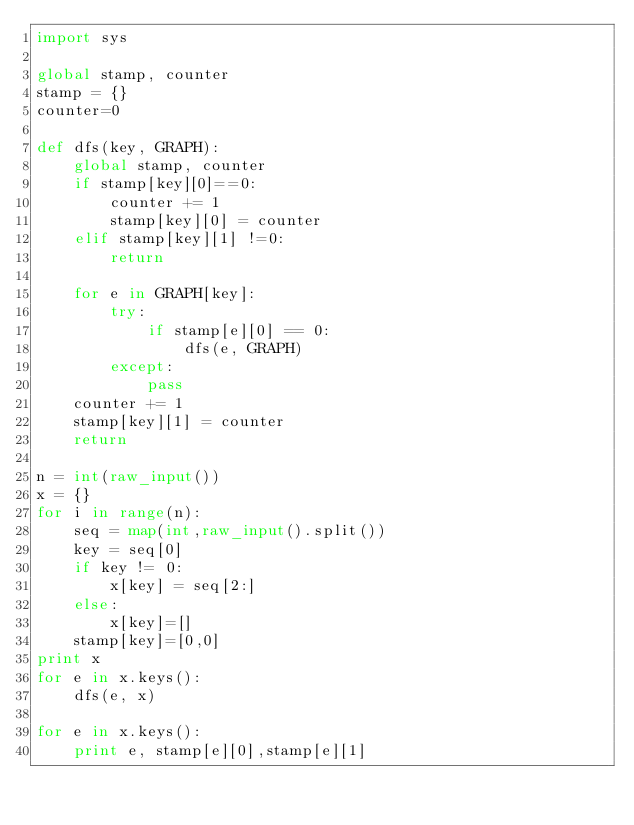<code> <loc_0><loc_0><loc_500><loc_500><_Python_>import sys

global stamp, counter
stamp = {}
counter=0

def dfs(key, GRAPH):
    global stamp, counter
    if stamp[key][0]==0:
        counter += 1
        stamp[key][0] = counter
    elif stamp[key][1] !=0:
        return

    for e in GRAPH[key]:
        try:
            if stamp[e][0] == 0:
                dfs(e, GRAPH)
        except:
            pass
    counter += 1
    stamp[key][1] = counter
    return

n = int(raw_input())
x = {}
for i in range(n):
    seq = map(int,raw_input().split())
    key = seq[0]
    if key != 0:
        x[key] = seq[2:]
    else:
        x[key]=[]
    stamp[key]=[0,0]
print x
for e in x.keys():
    dfs(e, x)

for e in x.keys():
    print e, stamp[e][0],stamp[e][1]</code> 